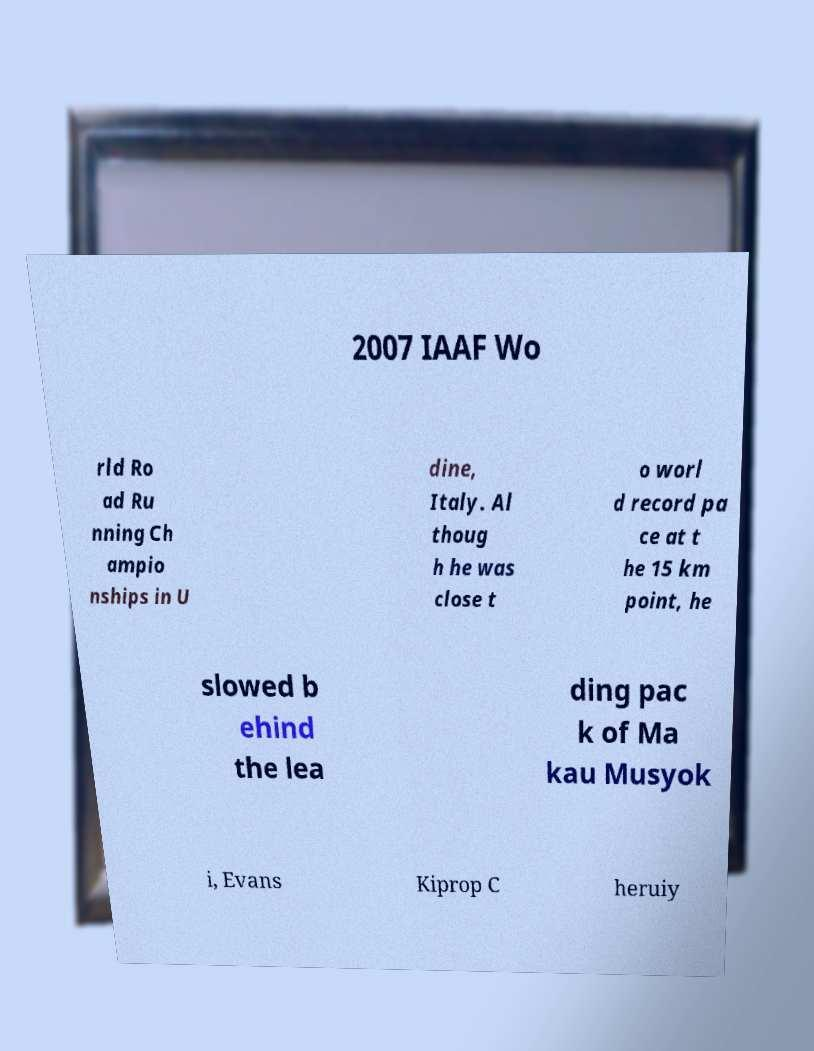I need the written content from this picture converted into text. Can you do that? 2007 IAAF Wo rld Ro ad Ru nning Ch ampio nships in U dine, Italy. Al thoug h he was close t o worl d record pa ce at t he 15 km point, he slowed b ehind the lea ding pac k of Ma kau Musyok i, Evans Kiprop C heruiy 